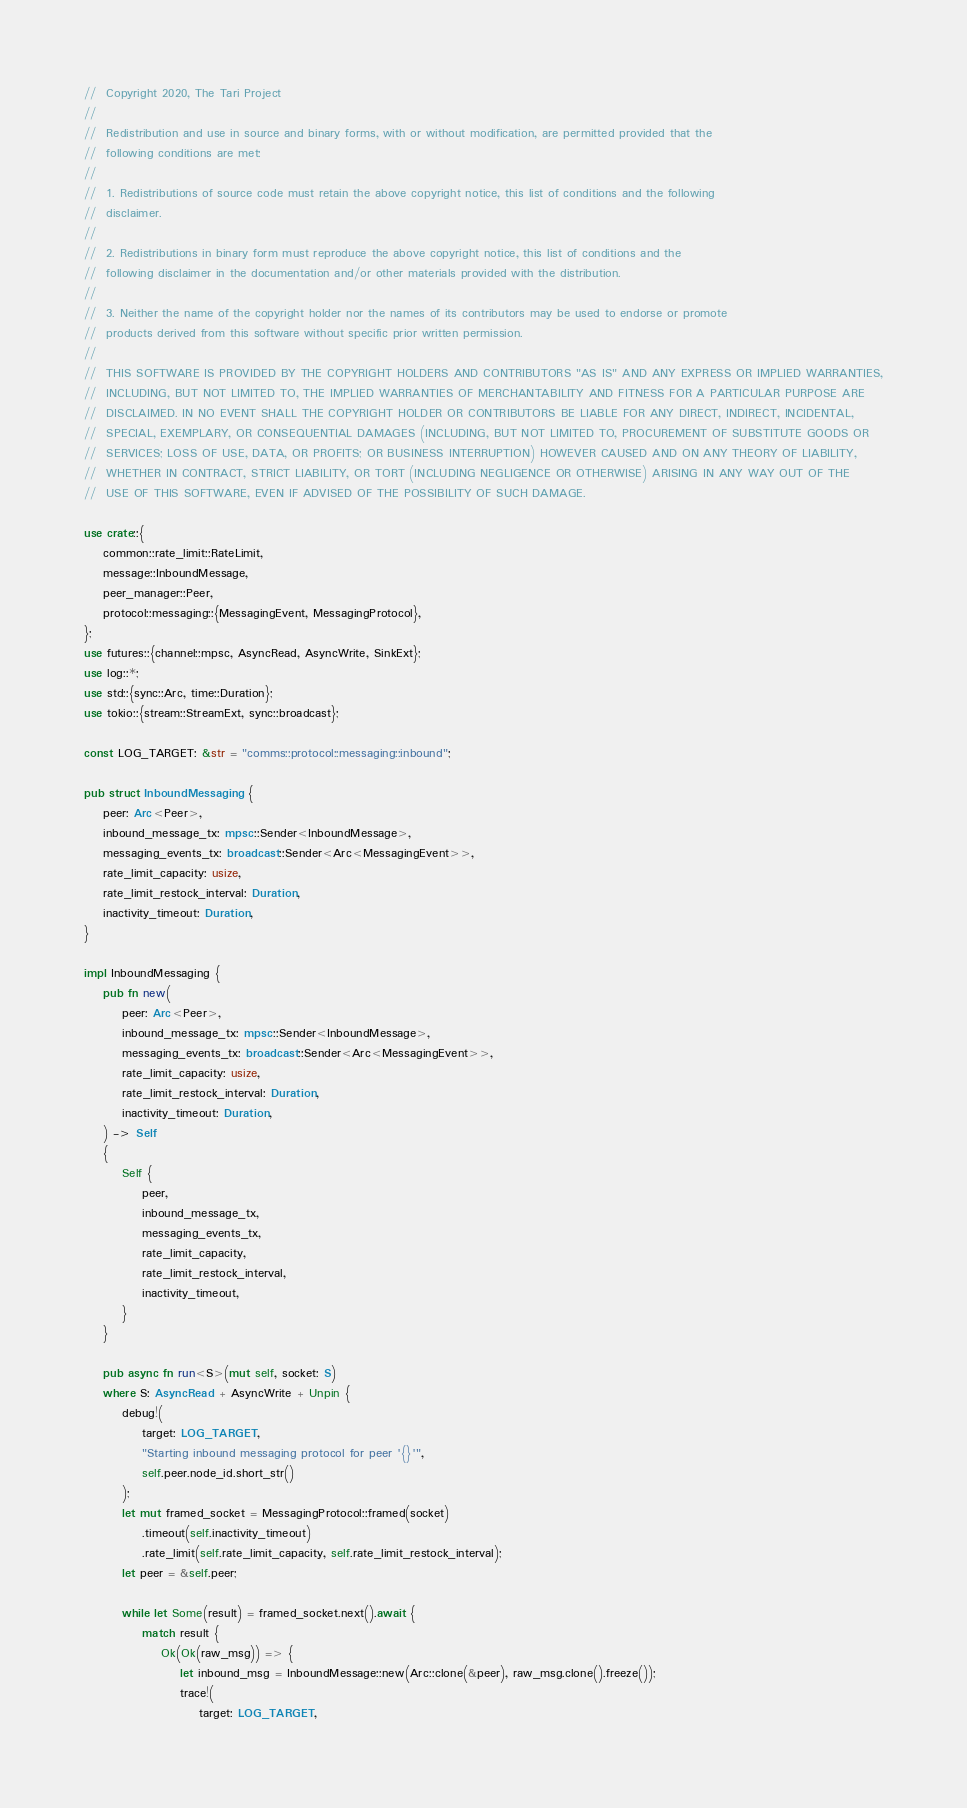<code> <loc_0><loc_0><loc_500><loc_500><_Rust_>//  Copyright 2020, The Tari Project
//
//  Redistribution and use in source and binary forms, with or without modification, are permitted provided that the
//  following conditions are met:
//
//  1. Redistributions of source code must retain the above copyright notice, this list of conditions and the following
//  disclaimer.
//
//  2. Redistributions in binary form must reproduce the above copyright notice, this list of conditions and the
//  following disclaimer in the documentation and/or other materials provided with the distribution.
//
//  3. Neither the name of the copyright holder nor the names of its contributors may be used to endorse or promote
//  products derived from this software without specific prior written permission.
//
//  THIS SOFTWARE IS PROVIDED BY THE COPYRIGHT HOLDERS AND CONTRIBUTORS "AS IS" AND ANY EXPRESS OR IMPLIED WARRANTIES,
//  INCLUDING, BUT NOT LIMITED TO, THE IMPLIED WARRANTIES OF MERCHANTABILITY AND FITNESS FOR A PARTICULAR PURPOSE ARE
//  DISCLAIMED. IN NO EVENT SHALL THE COPYRIGHT HOLDER OR CONTRIBUTORS BE LIABLE FOR ANY DIRECT, INDIRECT, INCIDENTAL,
//  SPECIAL, EXEMPLARY, OR CONSEQUENTIAL DAMAGES (INCLUDING, BUT NOT LIMITED TO, PROCUREMENT OF SUBSTITUTE GOODS OR
//  SERVICES; LOSS OF USE, DATA, OR PROFITS; OR BUSINESS INTERRUPTION) HOWEVER CAUSED AND ON ANY THEORY OF LIABILITY,
//  WHETHER IN CONTRACT, STRICT LIABILITY, OR TORT (INCLUDING NEGLIGENCE OR OTHERWISE) ARISING IN ANY WAY OUT OF THE
//  USE OF THIS SOFTWARE, EVEN IF ADVISED OF THE POSSIBILITY OF SUCH DAMAGE.

use crate::{
    common::rate_limit::RateLimit,
    message::InboundMessage,
    peer_manager::Peer,
    protocol::messaging::{MessagingEvent, MessagingProtocol},
};
use futures::{channel::mpsc, AsyncRead, AsyncWrite, SinkExt};
use log::*;
use std::{sync::Arc, time::Duration};
use tokio::{stream::StreamExt, sync::broadcast};

const LOG_TARGET: &str = "comms::protocol::messaging::inbound";

pub struct InboundMessaging {
    peer: Arc<Peer>,
    inbound_message_tx: mpsc::Sender<InboundMessage>,
    messaging_events_tx: broadcast::Sender<Arc<MessagingEvent>>,
    rate_limit_capacity: usize,
    rate_limit_restock_interval: Duration,
    inactivity_timeout: Duration,
}

impl InboundMessaging {
    pub fn new(
        peer: Arc<Peer>,
        inbound_message_tx: mpsc::Sender<InboundMessage>,
        messaging_events_tx: broadcast::Sender<Arc<MessagingEvent>>,
        rate_limit_capacity: usize,
        rate_limit_restock_interval: Duration,
        inactivity_timeout: Duration,
    ) -> Self
    {
        Self {
            peer,
            inbound_message_tx,
            messaging_events_tx,
            rate_limit_capacity,
            rate_limit_restock_interval,
            inactivity_timeout,
        }
    }

    pub async fn run<S>(mut self, socket: S)
    where S: AsyncRead + AsyncWrite + Unpin {
        debug!(
            target: LOG_TARGET,
            "Starting inbound messaging protocol for peer '{}'",
            self.peer.node_id.short_str()
        );
        let mut framed_socket = MessagingProtocol::framed(socket)
            .timeout(self.inactivity_timeout)
            .rate_limit(self.rate_limit_capacity, self.rate_limit_restock_interval);
        let peer = &self.peer;

        while let Some(result) = framed_socket.next().await {
            match result {
                Ok(Ok(raw_msg)) => {
                    let inbound_msg = InboundMessage::new(Arc::clone(&peer), raw_msg.clone().freeze());
                    trace!(
                        target: LOG_TARGET,</code> 